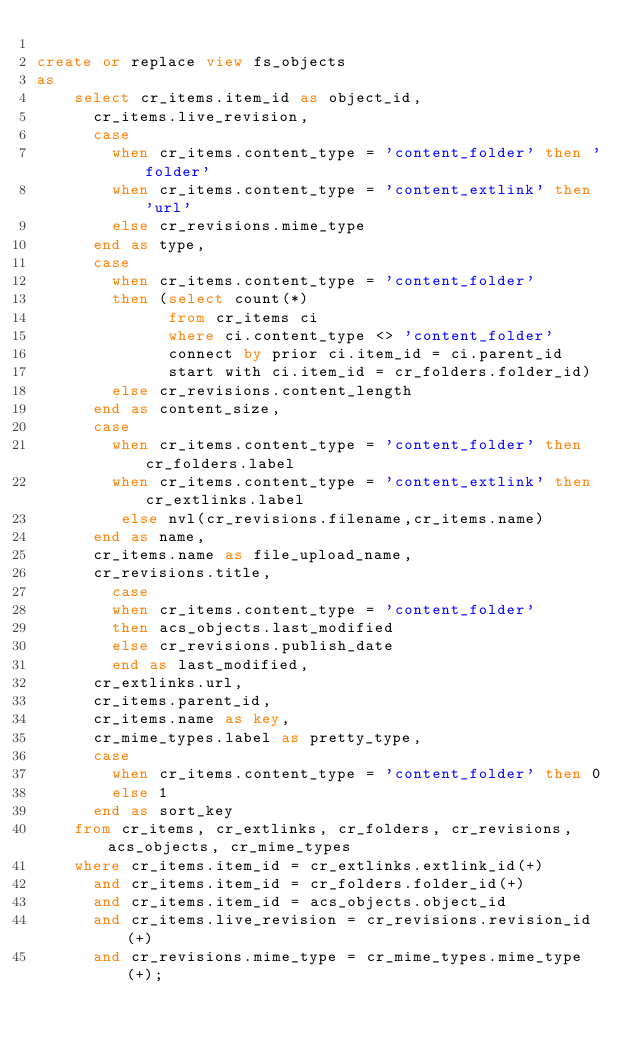<code> <loc_0><loc_0><loc_500><loc_500><_SQL_>
create or replace view fs_objects
as
    select cr_items.item_id as object_id,
      cr_items.live_revision,
      case
        when cr_items.content_type = 'content_folder' then 'folder'
        when cr_items.content_type = 'content_extlink' then 'url'
        else cr_revisions.mime_type
      end as type,
      case
        when cr_items.content_type = 'content_folder'
        then (select count(*)
              from cr_items ci
              where ci.content_type <> 'content_folder'
              connect by prior ci.item_id = ci.parent_id
              start with ci.item_id = cr_folders.folder_id)
        else cr_revisions.content_length
      end as content_size,
      case
        when cr_items.content_type = 'content_folder' then cr_folders.label
        when cr_items.content_type = 'content_extlink' then cr_extlinks.label
         else nvl(cr_revisions.filename,cr_items.name)
      end as name,
      cr_items.name as file_upload_name,
      cr_revisions.title,
        case
        when cr_items.content_type = 'content_folder'
        then acs_objects.last_modified
        else cr_revisions.publish_date
        end as last_modified,
      cr_extlinks.url,
      cr_items.parent_id,
      cr_items.name as key,
      cr_mime_types.label as pretty_type,
      case
        when cr_items.content_type = 'content_folder' then 0
        else 1
      end as sort_key
    from cr_items, cr_extlinks, cr_folders, cr_revisions, acs_objects, cr_mime_types
    where cr_items.item_id = cr_extlinks.extlink_id(+)
      and cr_items.item_id = cr_folders.folder_id(+)
      and cr_items.item_id = acs_objects.object_id
      and cr_items.live_revision = cr_revisions.revision_id(+)
      and cr_revisions.mime_type = cr_mime_types.mime_type(+);


</code> 